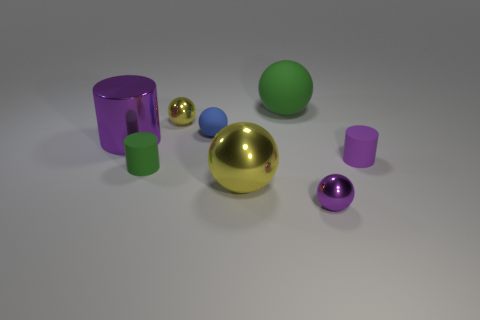Subtract all gray balls. Subtract all red cubes. How many balls are left? 5 Add 1 shiny cubes. How many objects exist? 9 Subtract all balls. How many objects are left? 3 Add 4 large purple metal cylinders. How many large purple metal cylinders are left? 5 Add 3 small rubber cylinders. How many small rubber cylinders exist? 5 Subtract 0 yellow cubes. How many objects are left? 8 Subtract all tiny gray cylinders. Subtract all purple metal things. How many objects are left? 6 